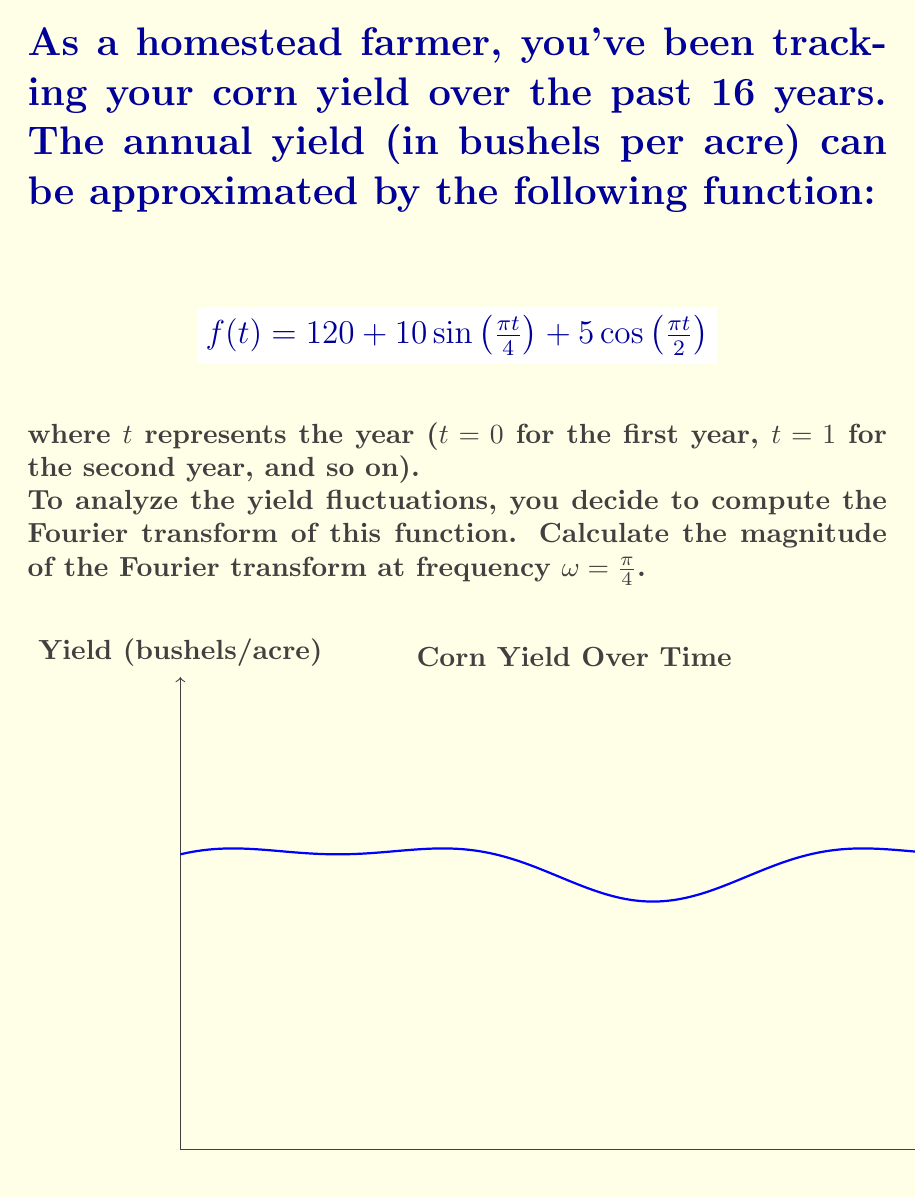Can you answer this question? Let's approach this step-by-step:

1) The Fourier transform of $f(t)$ is given by:

   $$F(\omega) = \int_{-\infty}^{\infty} f(t)e^{-i\omega t}dt$$

2) We need to compute $F(\frac{\pi}{4})$. Let's break down $f(t)$:

   $$f(t) = 120 + 10\sin(\frac{\pi t}{4}) + 5\cos(\frac{\pi t}{2})$$

3) The Fourier transform of a constant is a delta function at $\omega = 0$, so the 120 term will not contribute at $\omega = \frac{\pi}{4}$.

4) For the sine term, we can use the identity:

   $$\mathcal{F}\{sin(at)\} = \frac{i\pi}{2}[\delta(\omega-a) - \delta(\omega+a)]$$

   With $a = \frac{\pi}{4}$, this gives a contribution of $5\pi i$ at $\omega = \frac{\pi}{4}$.

5) For the cosine term, we use:

   $$\mathcal{F}\{cos(at)\} = \frac{\pi}{2}[\delta(\omega-a) + \delta(\omega+a)]$$

   With $a = \frac{\pi}{2}$, this term doesn't contribute at $\omega = \frac{\pi}{4}$.

6) Therefore, $F(\frac{\pi}{4}) = 5\pi i$

7) The magnitude of a complex number $z = a + bi$ is given by $\sqrt{a^2 + b^2}$

8) In this case, $|F(\frac{\pi}{4})| = \sqrt{0^2 + (5\pi)^2} = 5\pi$
Answer: $5\pi$ 